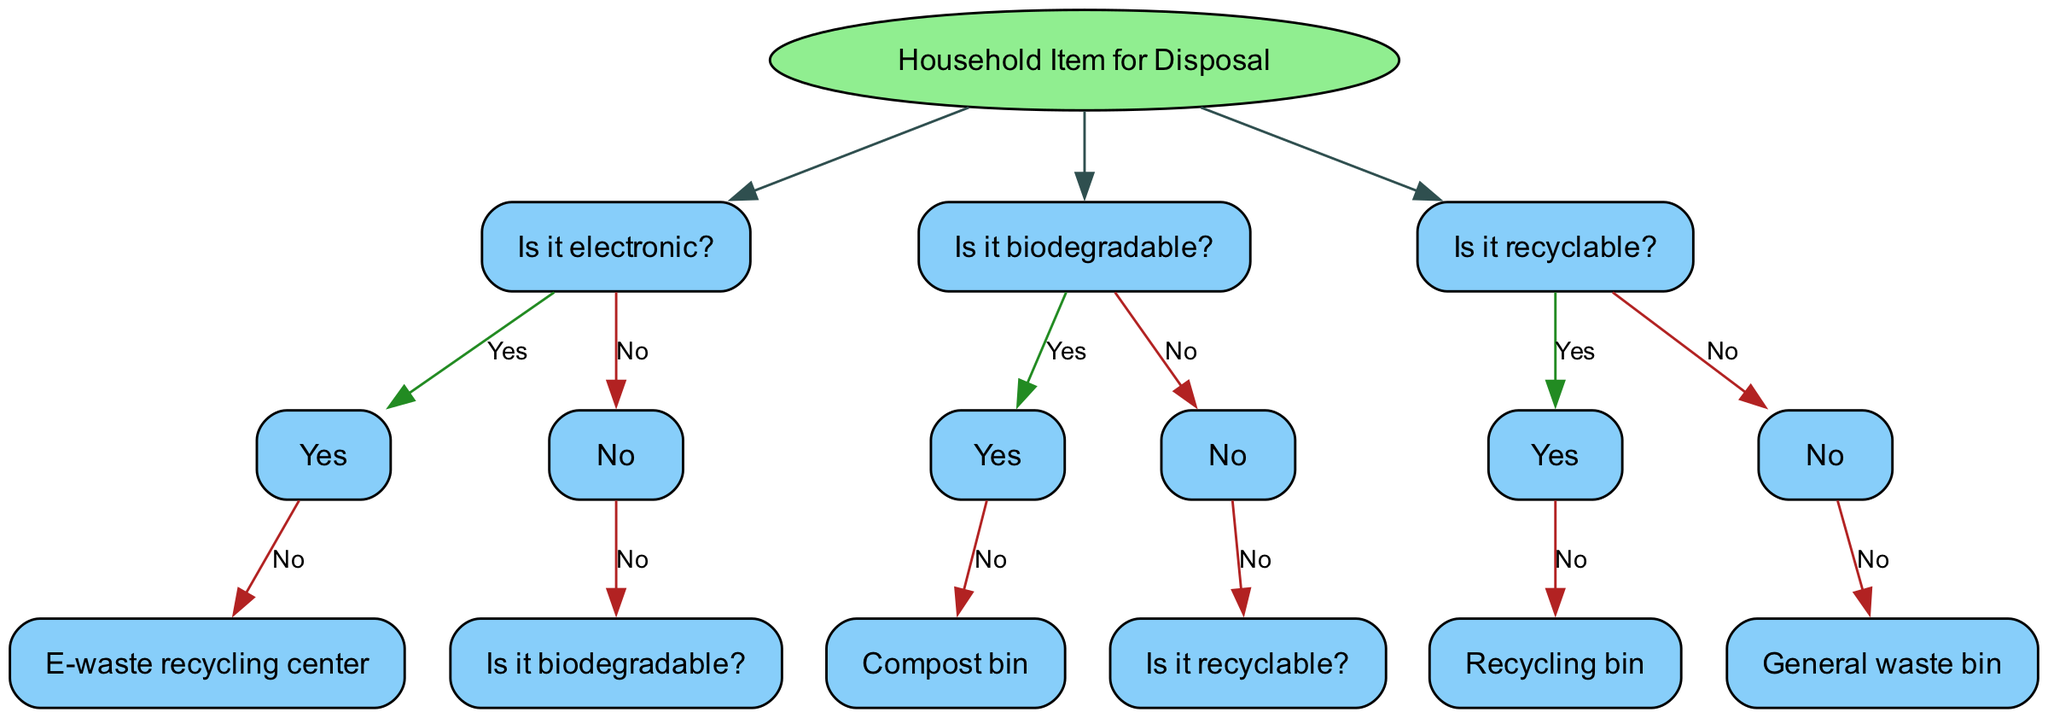What is the root node of the decision tree? The root node of the decision tree is "Household Item for Disposal," which represents the starting point for determining disposal methods for various household items.
Answer: Household Item for Disposal How many main decision nodes are there in the diagram? There are three main decision nodes in the diagram: "Is it electronic?", "Is it biodegradable?", and "Is it recyclable?". These nodes guide the user through the disposal process based on the characteristics of the item.
Answer: 3 What should you do if the answer to "Is it electronic?" is yes? If the answer to "Is it electronic?" is yes, the next action is to take it to an "E-waste recycling center," which is indicated as the next step in the tree.
Answer: E-waste recycling center If the item is not biodegradable and not recyclable, where should it go? If the item is neither biodegradable nor recyclable, it should go to the "General waste bin," which is the final step for such items as indicated in the decision tree.
Answer: General waste bin Which node indicates where to place biodegradable items? The node that provides information for biodegradable items is "Compost bin," which is the disposal method specified if the item is confirmed to be biodegradable.
Answer: Compost bin What is the concluding disposal method in the decision tree? The concluding disposal method in the decision tree is "General waste bin," which is reached if items are determined to be neither biodegradable nor recyclable.
Answer: General waste bin What does the decision node "Is it recyclable?" ask next after confirming it is not biodegradable? After confirming the item is not biodegradable, the decision node "Is it recyclable?" asks whether the item can be recycled, guiding the decision-making process based on this second question.
Answer: Is it recyclable? How is the "Recycling bin" categorized in the decision tree? The "Recycling bin" is categorized under the node "Is it recyclable?", indicating it is the appropriate disposal method for items that can be recycled as per the decision-making path.
Answer: Recycling bin What type of household items does this decision tree primarily focus on? This decision tree primarily focuses on household items for disposal, helping users determine the best waste management approach for various types of materials commonly found in homes.
Answer: Household items for disposal 